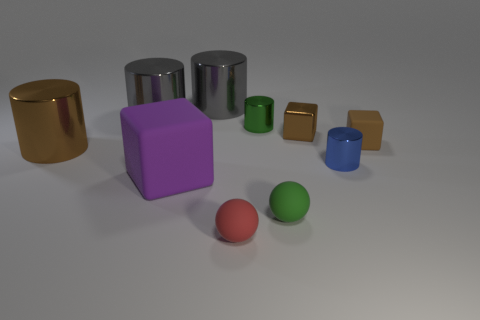Subtract all brown cylinders. How many cylinders are left? 4 Subtract all purple blocks. How many blocks are left? 2 Subtract all red cylinders. Subtract all brown cubes. How many cylinders are left? 5 Subtract all cyan blocks. How many purple balls are left? 0 Subtract all large purple cubes. Subtract all tiny matte things. How many objects are left? 6 Add 7 tiny brown metallic things. How many tiny brown metallic things are left? 8 Add 4 tiny things. How many tiny things exist? 10 Subtract 0 yellow cylinders. How many objects are left? 10 Subtract all cubes. How many objects are left? 7 Subtract 2 balls. How many balls are left? 0 